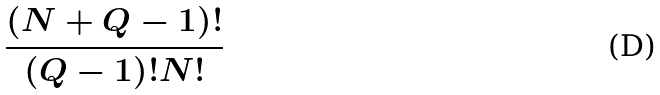Convert formula to latex. <formula><loc_0><loc_0><loc_500><loc_500>\frac { ( N + Q - 1 ) ! } { ( Q - 1 ) ! N ! }</formula> 